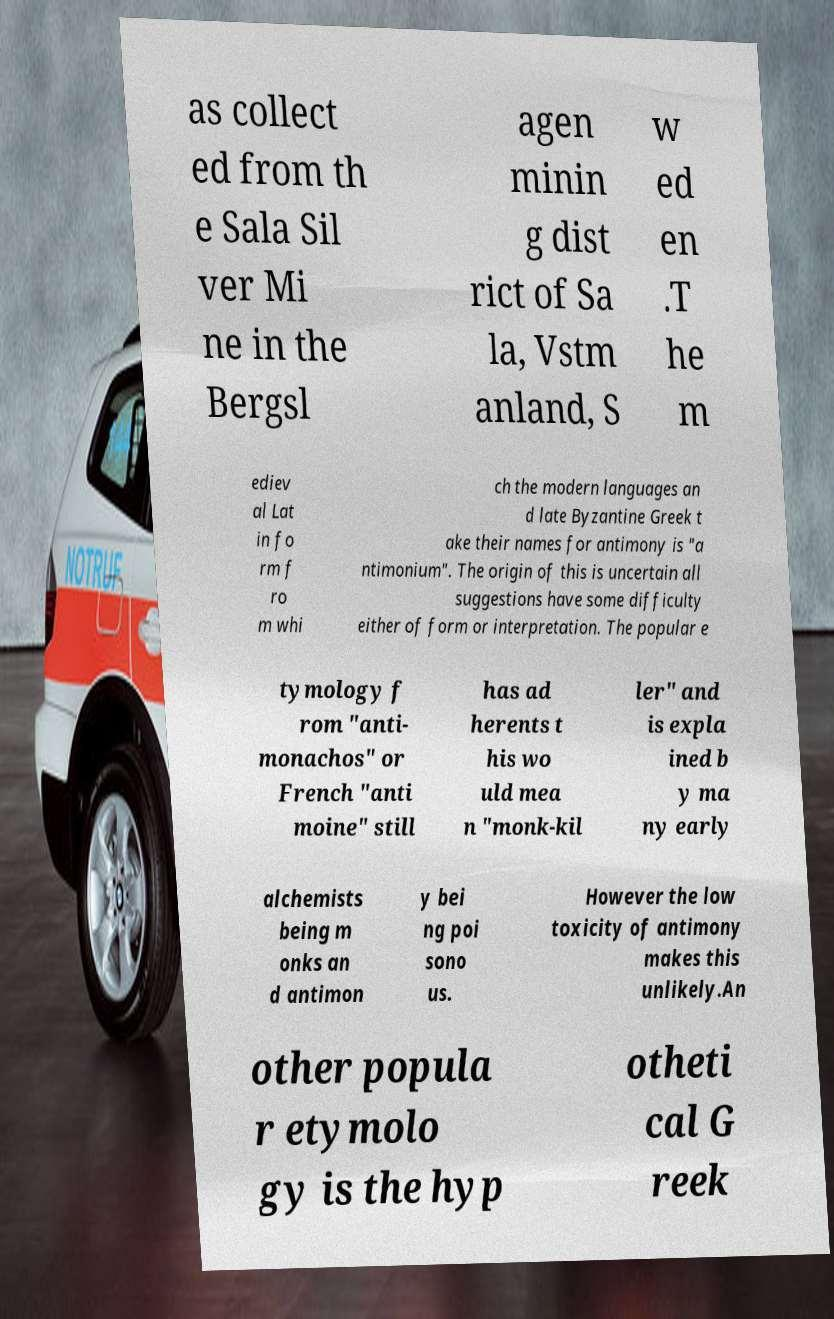What messages or text are displayed in this image? I need them in a readable, typed format. as collect ed from th e Sala Sil ver Mi ne in the Bergsl agen minin g dist rict of Sa la, Vstm anland, S w ed en .T he m ediev al Lat in fo rm f ro m whi ch the modern languages an d late Byzantine Greek t ake their names for antimony is "a ntimonium". The origin of this is uncertain all suggestions have some difficulty either of form or interpretation. The popular e tymology f rom "anti- monachos" or French "anti moine" still has ad herents t his wo uld mea n "monk-kil ler" and is expla ined b y ma ny early alchemists being m onks an d antimon y bei ng poi sono us. However the low toxicity of antimony makes this unlikely.An other popula r etymolo gy is the hyp otheti cal G reek 